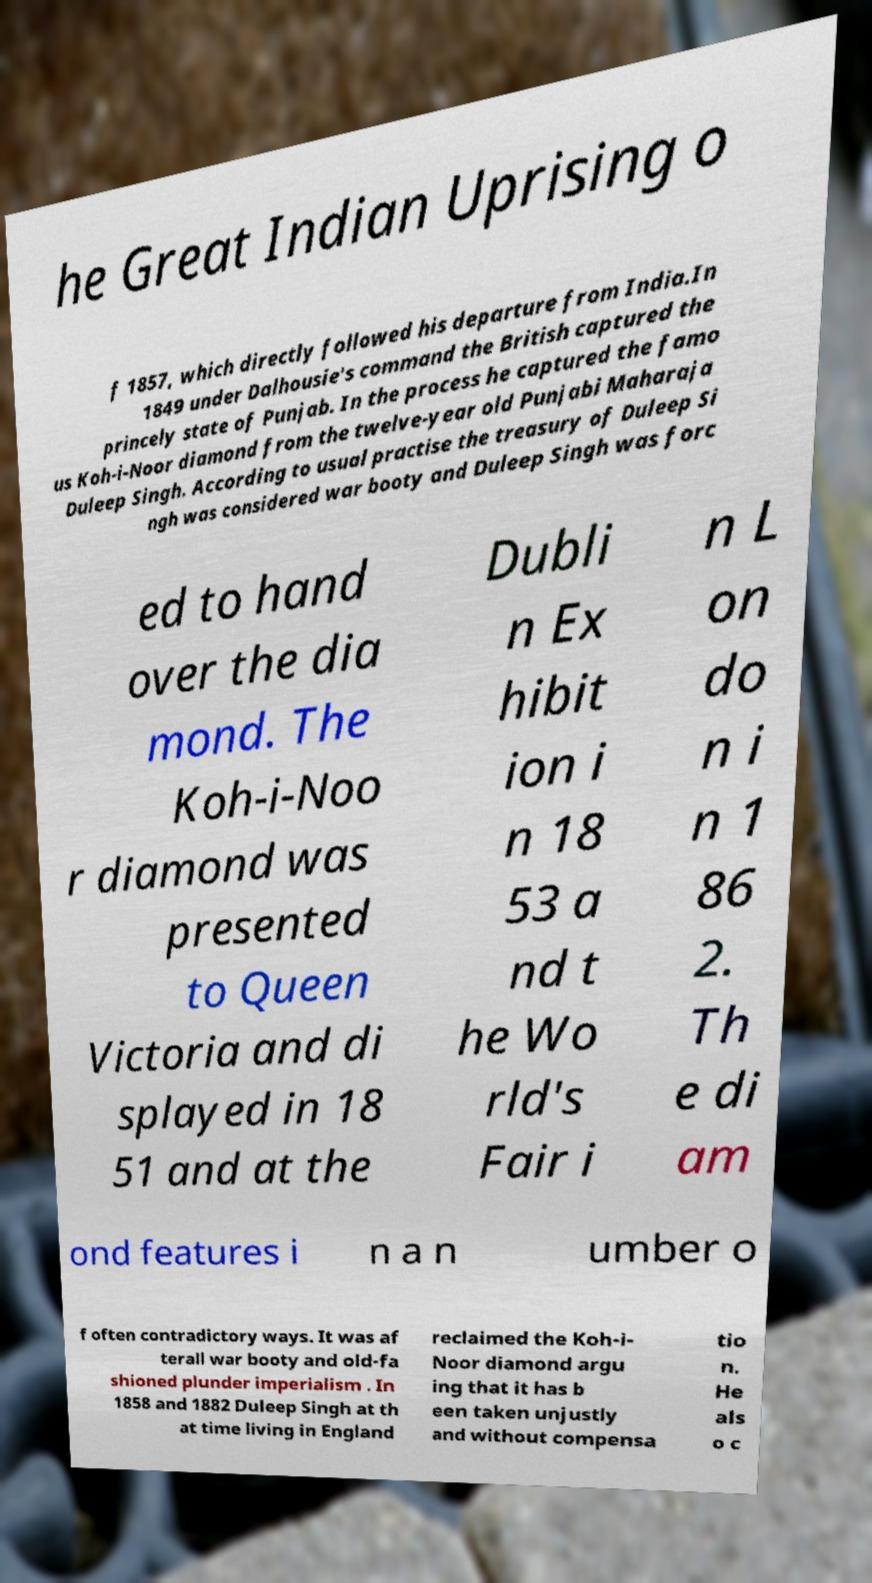Can you accurately transcribe the text from the provided image for me? he Great Indian Uprising o f 1857, which directly followed his departure from India.In 1849 under Dalhousie's command the British captured the princely state of Punjab. In the process he captured the famo us Koh-i-Noor diamond from the twelve-year old Punjabi Maharaja Duleep Singh. According to usual practise the treasury of Duleep Si ngh was considered war booty and Duleep Singh was forc ed to hand over the dia mond. The Koh-i-Noo r diamond was presented to Queen Victoria and di splayed in 18 51 and at the Dubli n Ex hibit ion i n 18 53 a nd t he Wo rld's Fair i n L on do n i n 1 86 2. Th e di am ond features i n a n umber o f often contradictory ways. It was af terall war booty and old-fa shioned plunder imperialism . In 1858 and 1882 Duleep Singh at th at time living in England reclaimed the Koh-i- Noor diamond argu ing that it has b een taken unjustly and without compensa tio n. He als o c 